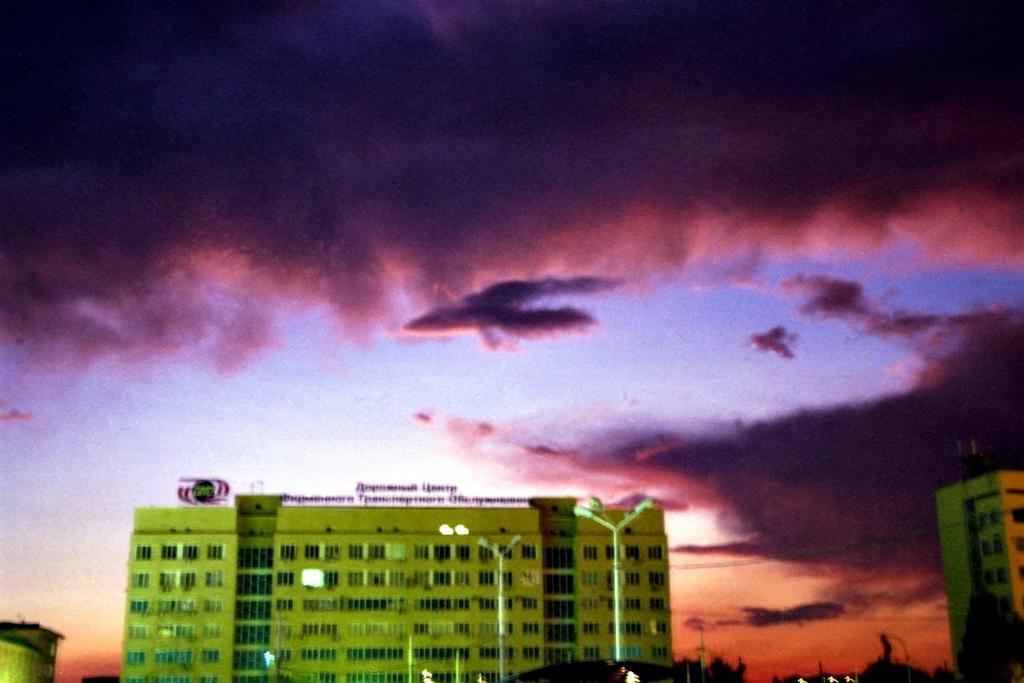Could you give a brief overview of what you see in this image? In this picture there is a building which has few street lights in front of it and there is some thing written above the building and there is a building on either sides of it and there are trees in the background and the sky is cloudy. 